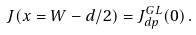Convert formula to latex. <formula><loc_0><loc_0><loc_500><loc_500>J ( x = W - d / 2 ) = J _ { d p } ^ { G L } ( 0 ) \, .</formula> 